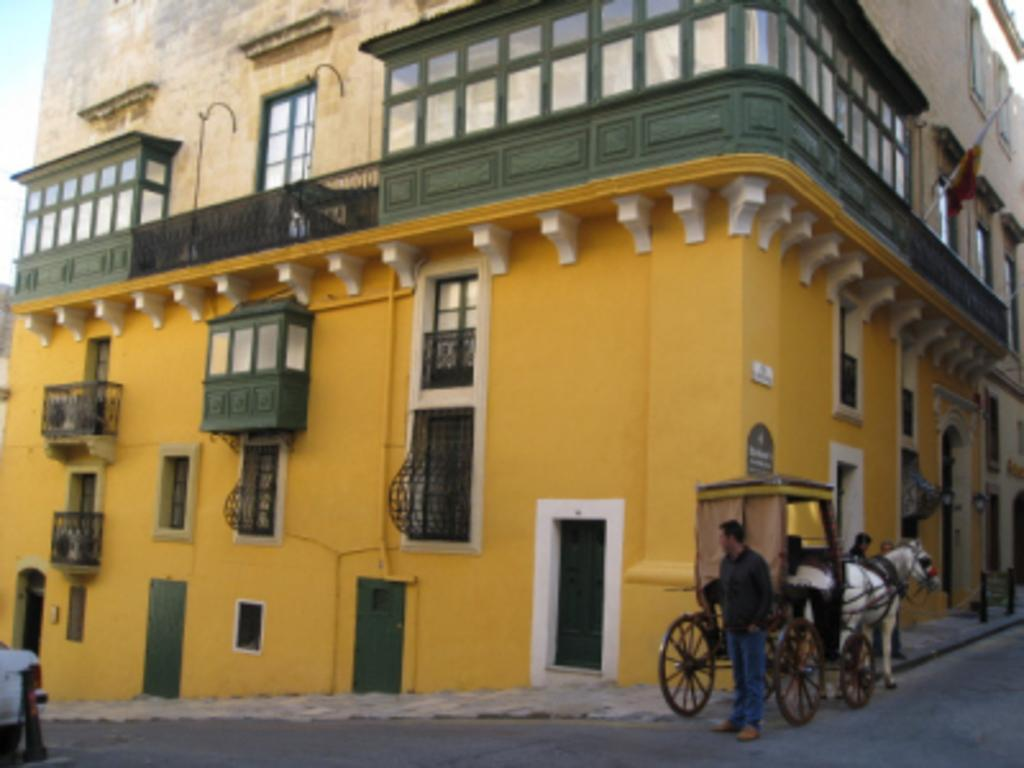What color is the building in the image? The building in the image is yellow. What can be seen on the road in the image? There is a horse cart on the road in the image. Are there any people visible in the image? Yes, a man is standing in the image. What type of yarn is being used to create the slope in the image? There is no yarn or slope present in the image. How many mice can be seen running around the yellow building in the image? There are no mice visible in the image; it features a yellow building and a horse cart on the road. 